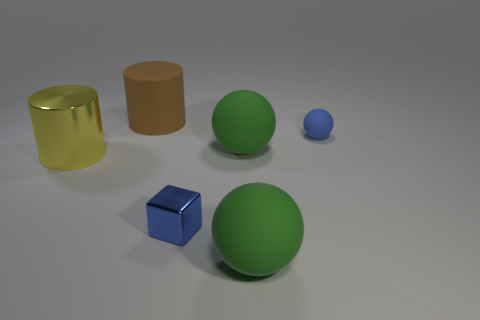Could you describe the colors of the objects? Certainly! There are two green spheres, with the larger one being a darker shade of green. There's a golden yellow transparent cylinder, a brown opaque cylinder, a small blue sphere, and a blue cube with a slightly reflective surface. 